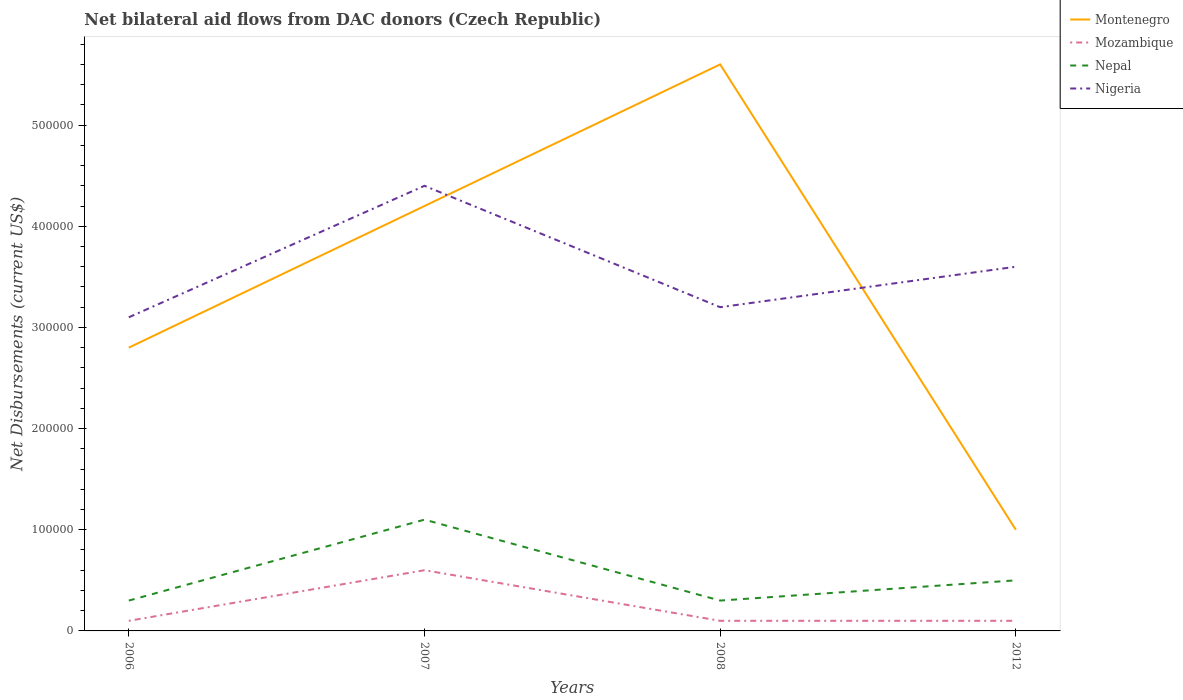Is the number of lines equal to the number of legend labels?
Give a very brief answer. Yes. Across all years, what is the maximum net bilateral aid flows in Montenegro?
Your answer should be compact. 1.00e+05. In which year was the net bilateral aid flows in Nigeria maximum?
Make the answer very short. 2006. What is the difference between the highest and the second highest net bilateral aid flows in Nepal?
Make the answer very short. 8.00e+04. What is the difference between the highest and the lowest net bilateral aid flows in Mozambique?
Provide a succinct answer. 1. How many years are there in the graph?
Keep it short and to the point. 4. What is the difference between two consecutive major ticks on the Y-axis?
Your answer should be very brief. 1.00e+05. Are the values on the major ticks of Y-axis written in scientific E-notation?
Your answer should be compact. No. Where does the legend appear in the graph?
Your answer should be compact. Top right. How are the legend labels stacked?
Give a very brief answer. Vertical. What is the title of the graph?
Offer a terse response. Net bilateral aid flows from DAC donors (Czech Republic). What is the label or title of the Y-axis?
Make the answer very short. Net Disbursements (current US$). What is the Net Disbursements (current US$) in Montenegro in 2006?
Give a very brief answer. 2.80e+05. What is the Net Disbursements (current US$) in Mozambique in 2006?
Provide a short and direct response. 10000. What is the Net Disbursements (current US$) in Nepal in 2006?
Your response must be concise. 3.00e+04. What is the Net Disbursements (current US$) of Montenegro in 2007?
Provide a short and direct response. 4.20e+05. What is the Net Disbursements (current US$) in Montenegro in 2008?
Provide a short and direct response. 5.60e+05. What is the Net Disbursements (current US$) of Mozambique in 2008?
Offer a terse response. 10000. What is the Net Disbursements (current US$) in Nepal in 2008?
Offer a very short reply. 3.00e+04. What is the Net Disbursements (current US$) in Nigeria in 2012?
Offer a very short reply. 3.60e+05. Across all years, what is the maximum Net Disbursements (current US$) in Montenegro?
Ensure brevity in your answer.  5.60e+05. Across all years, what is the maximum Net Disbursements (current US$) of Mozambique?
Keep it short and to the point. 6.00e+04. Across all years, what is the minimum Net Disbursements (current US$) of Nepal?
Provide a short and direct response. 3.00e+04. Across all years, what is the minimum Net Disbursements (current US$) of Nigeria?
Ensure brevity in your answer.  3.10e+05. What is the total Net Disbursements (current US$) in Montenegro in the graph?
Provide a short and direct response. 1.36e+06. What is the total Net Disbursements (current US$) of Mozambique in the graph?
Give a very brief answer. 9.00e+04. What is the total Net Disbursements (current US$) of Nepal in the graph?
Offer a very short reply. 2.20e+05. What is the total Net Disbursements (current US$) in Nigeria in the graph?
Keep it short and to the point. 1.43e+06. What is the difference between the Net Disbursements (current US$) in Nepal in 2006 and that in 2007?
Provide a succinct answer. -8.00e+04. What is the difference between the Net Disbursements (current US$) of Nigeria in 2006 and that in 2007?
Make the answer very short. -1.30e+05. What is the difference between the Net Disbursements (current US$) in Montenegro in 2006 and that in 2008?
Your answer should be very brief. -2.80e+05. What is the difference between the Net Disbursements (current US$) in Nigeria in 2006 and that in 2008?
Provide a succinct answer. -10000. What is the difference between the Net Disbursements (current US$) in Nepal in 2006 and that in 2012?
Your answer should be compact. -2.00e+04. What is the difference between the Net Disbursements (current US$) of Mozambique in 2007 and that in 2008?
Ensure brevity in your answer.  5.00e+04. What is the difference between the Net Disbursements (current US$) of Nigeria in 2007 and that in 2008?
Provide a succinct answer. 1.20e+05. What is the difference between the Net Disbursements (current US$) of Mozambique in 2007 and that in 2012?
Keep it short and to the point. 5.00e+04. What is the difference between the Net Disbursements (current US$) of Nigeria in 2007 and that in 2012?
Offer a very short reply. 8.00e+04. What is the difference between the Net Disbursements (current US$) in Montenegro in 2008 and that in 2012?
Provide a succinct answer. 4.60e+05. What is the difference between the Net Disbursements (current US$) in Mozambique in 2008 and that in 2012?
Keep it short and to the point. 0. What is the difference between the Net Disbursements (current US$) of Nepal in 2008 and that in 2012?
Offer a terse response. -2.00e+04. What is the difference between the Net Disbursements (current US$) of Nigeria in 2008 and that in 2012?
Keep it short and to the point. -4.00e+04. What is the difference between the Net Disbursements (current US$) in Montenegro in 2006 and the Net Disbursements (current US$) in Nigeria in 2007?
Provide a succinct answer. -1.60e+05. What is the difference between the Net Disbursements (current US$) in Mozambique in 2006 and the Net Disbursements (current US$) in Nigeria in 2007?
Your response must be concise. -4.30e+05. What is the difference between the Net Disbursements (current US$) of Nepal in 2006 and the Net Disbursements (current US$) of Nigeria in 2007?
Your answer should be very brief. -4.10e+05. What is the difference between the Net Disbursements (current US$) in Montenegro in 2006 and the Net Disbursements (current US$) in Nepal in 2008?
Provide a succinct answer. 2.50e+05. What is the difference between the Net Disbursements (current US$) in Mozambique in 2006 and the Net Disbursements (current US$) in Nepal in 2008?
Your answer should be compact. -2.00e+04. What is the difference between the Net Disbursements (current US$) in Mozambique in 2006 and the Net Disbursements (current US$) in Nigeria in 2008?
Provide a short and direct response. -3.10e+05. What is the difference between the Net Disbursements (current US$) of Montenegro in 2006 and the Net Disbursements (current US$) of Nepal in 2012?
Your answer should be very brief. 2.30e+05. What is the difference between the Net Disbursements (current US$) in Montenegro in 2006 and the Net Disbursements (current US$) in Nigeria in 2012?
Provide a succinct answer. -8.00e+04. What is the difference between the Net Disbursements (current US$) in Mozambique in 2006 and the Net Disbursements (current US$) in Nigeria in 2012?
Keep it short and to the point. -3.50e+05. What is the difference between the Net Disbursements (current US$) in Nepal in 2006 and the Net Disbursements (current US$) in Nigeria in 2012?
Your answer should be compact. -3.30e+05. What is the difference between the Net Disbursements (current US$) in Montenegro in 2007 and the Net Disbursements (current US$) in Nepal in 2008?
Your response must be concise. 3.90e+05. What is the difference between the Net Disbursements (current US$) of Montenegro in 2007 and the Net Disbursements (current US$) of Nigeria in 2008?
Ensure brevity in your answer.  1.00e+05. What is the difference between the Net Disbursements (current US$) of Mozambique in 2007 and the Net Disbursements (current US$) of Nigeria in 2008?
Keep it short and to the point. -2.60e+05. What is the difference between the Net Disbursements (current US$) in Nepal in 2007 and the Net Disbursements (current US$) in Nigeria in 2008?
Ensure brevity in your answer.  -2.10e+05. What is the difference between the Net Disbursements (current US$) in Montenegro in 2007 and the Net Disbursements (current US$) in Nepal in 2012?
Provide a short and direct response. 3.70e+05. What is the difference between the Net Disbursements (current US$) of Mozambique in 2007 and the Net Disbursements (current US$) of Nepal in 2012?
Offer a very short reply. 10000. What is the difference between the Net Disbursements (current US$) in Montenegro in 2008 and the Net Disbursements (current US$) in Mozambique in 2012?
Offer a terse response. 5.50e+05. What is the difference between the Net Disbursements (current US$) in Montenegro in 2008 and the Net Disbursements (current US$) in Nepal in 2012?
Make the answer very short. 5.10e+05. What is the difference between the Net Disbursements (current US$) of Montenegro in 2008 and the Net Disbursements (current US$) of Nigeria in 2012?
Your response must be concise. 2.00e+05. What is the difference between the Net Disbursements (current US$) in Mozambique in 2008 and the Net Disbursements (current US$) in Nepal in 2012?
Give a very brief answer. -4.00e+04. What is the difference between the Net Disbursements (current US$) of Mozambique in 2008 and the Net Disbursements (current US$) of Nigeria in 2012?
Offer a terse response. -3.50e+05. What is the difference between the Net Disbursements (current US$) in Nepal in 2008 and the Net Disbursements (current US$) in Nigeria in 2012?
Make the answer very short. -3.30e+05. What is the average Net Disbursements (current US$) of Mozambique per year?
Offer a terse response. 2.25e+04. What is the average Net Disbursements (current US$) of Nepal per year?
Your answer should be very brief. 5.50e+04. What is the average Net Disbursements (current US$) of Nigeria per year?
Make the answer very short. 3.58e+05. In the year 2006, what is the difference between the Net Disbursements (current US$) in Montenegro and Net Disbursements (current US$) in Nepal?
Give a very brief answer. 2.50e+05. In the year 2006, what is the difference between the Net Disbursements (current US$) in Montenegro and Net Disbursements (current US$) in Nigeria?
Provide a succinct answer. -3.00e+04. In the year 2006, what is the difference between the Net Disbursements (current US$) of Mozambique and Net Disbursements (current US$) of Nepal?
Make the answer very short. -2.00e+04. In the year 2006, what is the difference between the Net Disbursements (current US$) in Nepal and Net Disbursements (current US$) in Nigeria?
Your response must be concise. -2.80e+05. In the year 2007, what is the difference between the Net Disbursements (current US$) of Montenegro and Net Disbursements (current US$) of Nepal?
Offer a very short reply. 3.10e+05. In the year 2007, what is the difference between the Net Disbursements (current US$) in Montenegro and Net Disbursements (current US$) in Nigeria?
Give a very brief answer. -2.00e+04. In the year 2007, what is the difference between the Net Disbursements (current US$) in Mozambique and Net Disbursements (current US$) in Nigeria?
Offer a terse response. -3.80e+05. In the year 2007, what is the difference between the Net Disbursements (current US$) of Nepal and Net Disbursements (current US$) of Nigeria?
Provide a succinct answer. -3.30e+05. In the year 2008, what is the difference between the Net Disbursements (current US$) in Montenegro and Net Disbursements (current US$) in Nepal?
Offer a very short reply. 5.30e+05. In the year 2008, what is the difference between the Net Disbursements (current US$) in Mozambique and Net Disbursements (current US$) in Nepal?
Provide a short and direct response. -2.00e+04. In the year 2008, what is the difference between the Net Disbursements (current US$) in Mozambique and Net Disbursements (current US$) in Nigeria?
Offer a terse response. -3.10e+05. In the year 2012, what is the difference between the Net Disbursements (current US$) in Montenegro and Net Disbursements (current US$) in Mozambique?
Keep it short and to the point. 9.00e+04. In the year 2012, what is the difference between the Net Disbursements (current US$) in Mozambique and Net Disbursements (current US$) in Nigeria?
Give a very brief answer. -3.50e+05. In the year 2012, what is the difference between the Net Disbursements (current US$) in Nepal and Net Disbursements (current US$) in Nigeria?
Ensure brevity in your answer.  -3.10e+05. What is the ratio of the Net Disbursements (current US$) in Nepal in 2006 to that in 2007?
Your response must be concise. 0.27. What is the ratio of the Net Disbursements (current US$) in Nigeria in 2006 to that in 2007?
Offer a terse response. 0.7. What is the ratio of the Net Disbursements (current US$) of Mozambique in 2006 to that in 2008?
Your response must be concise. 1. What is the ratio of the Net Disbursements (current US$) of Nepal in 2006 to that in 2008?
Make the answer very short. 1. What is the ratio of the Net Disbursements (current US$) of Nigeria in 2006 to that in 2008?
Offer a terse response. 0.97. What is the ratio of the Net Disbursements (current US$) in Mozambique in 2006 to that in 2012?
Offer a terse response. 1. What is the ratio of the Net Disbursements (current US$) of Nigeria in 2006 to that in 2012?
Offer a very short reply. 0.86. What is the ratio of the Net Disbursements (current US$) of Mozambique in 2007 to that in 2008?
Keep it short and to the point. 6. What is the ratio of the Net Disbursements (current US$) in Nepal in 2007 to that in 2008?
Provide a short and direct response. 3.67. What is the ratio of the Net Disbursements (current US$) of Nigeria in 2007 to that in 2008?
Offer a very short reply. 1.38. What is the ratio of the Net Disbursements (current US$) in Mozambique in 2007 to that in 2012?
Make the answer very short. 6. What is the ratio of the Net Disbursements (current US$) in Nepal in 2007 to that in 2012?
Provide a succinct answer. 2.2. What is the ratio of the Net Disbursements (current US$) of Nigeria in 2007 to that in 2012?
Keep it short and to the point. 1.22. What is the difference between the highest and the second highest Net Disbursements (current US$) of Montenegro?
Your answer should be compact. 1.40e+05. What is the difference between the highest and the second highest Net Disbursements (current US$) of Mozambique?
Your response must be concise. 5.00e+04. What is the difference between the highest and the second highest Net Disbursements (current US$) in Nigeria?
Your response must be concise. 8.00e+04. What is the difference between the highest and the lowest Net Disbursements (current US$) of Montenegro?
Keep it short and to the point. 4.60e+05. What is the difference between the highest and the lowest Net Disbursements (current US$) in Nepal?
Offer a terse response. 8.00e+04. What is the difference between the highest and the lowest Net Disbursements (current US$) of Nigeria?
Provide a succinct answer. 1.30e+05. 